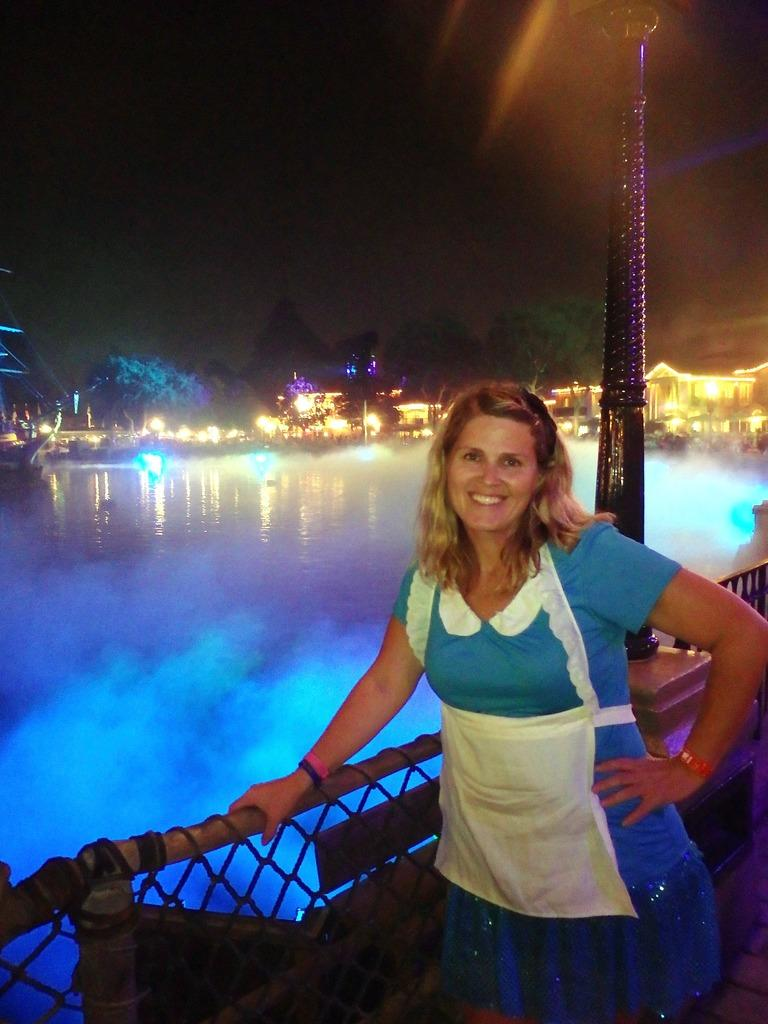Who is present in the image? There is a lady in the image. What is the lady wearing? The lady is wearing a blue and white dress. Where is the lady standing in relation to the fencing? The lady is standing beside the fencing. What can be seen in the background of the image? There is water, buildings, and trees visible in the image. What type of lighting is present in the image? There are lights in the image. What type of hall can be seen in the image? There is no hall present in the image. Can you tell me how many tramps are visible in the image? There are no tramps present in the image. 